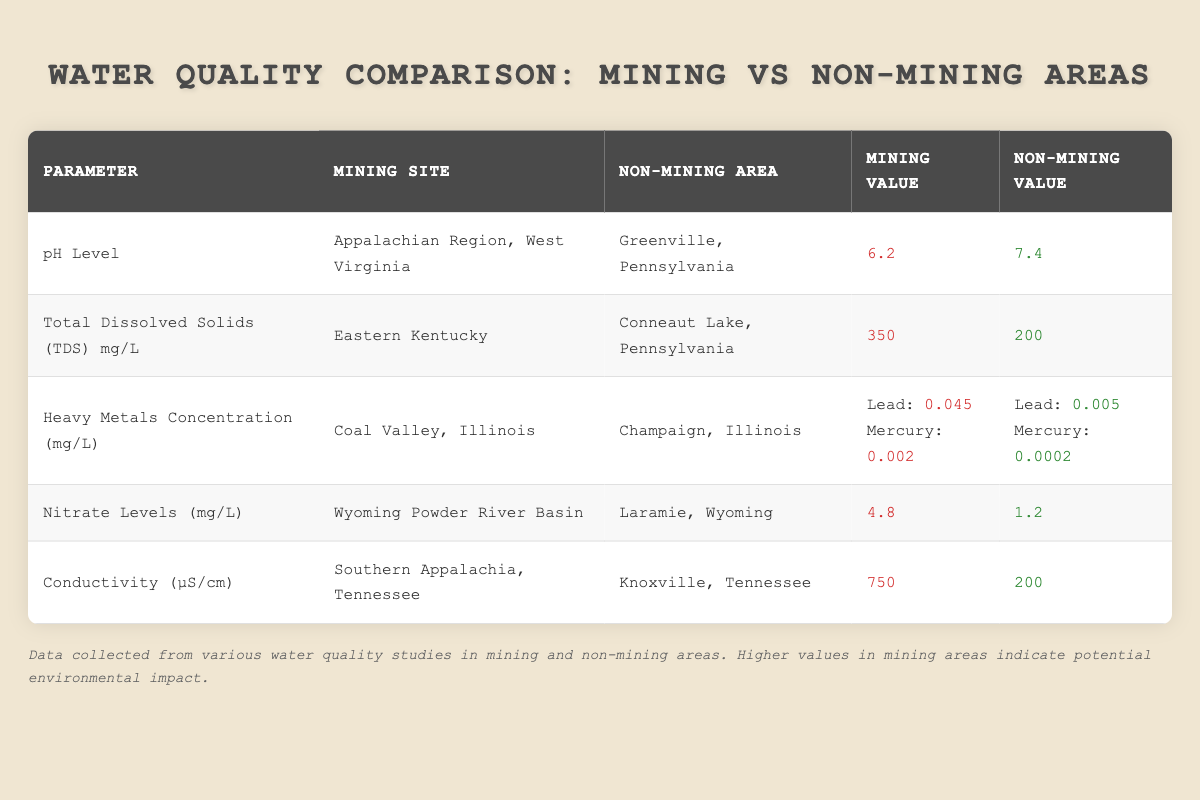What is the pH level in the mining site? According to the table, the pH level in the mining site located in the Appalachian Region, West Virginia is listed as 6.2.
Answer: 6.2 What are the Total Dissolved Solids (TDS) levels in the non-mining area? The table indicates that the Total Dissolved Solids (TDS) level in the non-mining area of Conneaut Lake, Pennsylvania is 200 mg/L.
Answer: 200 mg/L Is the Heavy Metals Concentration for lead higher in mining or non-mining areas? The lead concentration in the mining area (Coal Valley, Illinois) is 0.045 mg/L, while in the non-mining area (Champaign, Illinois) it is 0.005 mg/L. Since 0.045 is greater than 0.005, the lead concentration is indeed higher in the mining area.
Answer: Yes What is the difference in Nitrate Levels between mining and non-mining areas? The Nitrate Level in the mining area (Wyoming Powder River Basin) is 4.8 mg/L and in the non-mining area (Laramie, Wyoming) it is 1.2 mg/L. The difference is calculated as 4.8 - 1.2 = 3.6 mg/L.
Answer: 3.6 mg/L Which parameter shows the highest value in mining areas, and what is that value? Reviewing the table, the parameter with the highest value in mining areas is Conductivity in Southern Appalachia, Tennessee, at 750 µS/cm.
Answer: Conductivity, 750 µS/cm How much higher is the Total Dissolved Solids (TDS) level in mining areas compared to non-mining areas? The TDS level in mining areas (Eastern Kentucky) is 350 mg/L, while in non-mining areas (Conneaut Lake, Pennsylvania) it is 200 mg/L. The difference in TDS levels is 350 - 200 = 150 mg/L.
Answer: 150 mg/L Is it true that pH levels are generally lower in mining areas compared to non-mining areas? The mining area's pH level is 6.2, while the non-mining area's pH level is 7.4. Since 6.2 is less than 7.4, this statement is true.
Answer: Yes What is the average Heavy Metals Concentration for mercury in mining areas? There is one recorded value for mercury in the mining area (Coal Valley, Illinois), which is 0.002 mg/L. Since there's only one value, the average is the same as that value, which is 0.002 mg/L.
Answer: 0.002 mg/L Compare the conductivity levels: which area has a higher conductivity and by how much? The conductivity level in the mining area (Southern Appalachia, Tennessee) is 750 µS/cm and in the non-mining area (Knoxville, Tennessee) it is 200 µS/cm. The difference is 750 - 200 = 550 µS/cm. Therefore, the mining area has higher conductivity by 550 µS/cm.
Answer: Higher by 550 µS/cm 